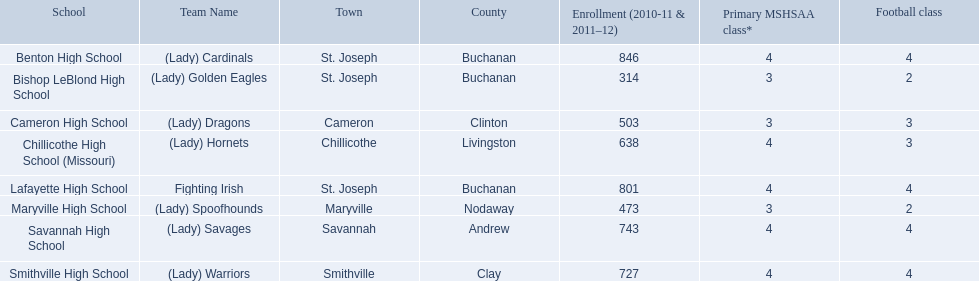What is the smallest number of students attending a school as shown here? 314. What institution has 314 students in attendance? Bishop LeBlond High School. 